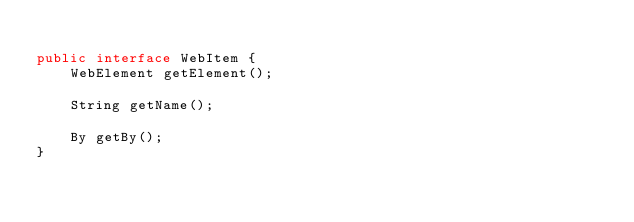Convert code to text. <code><loc_0><loc_0><loc_500><loc_500><_Java_>
public interface WebItem {
    WebElement getElement();

    String getName();

    By getBy();
}
</code> 